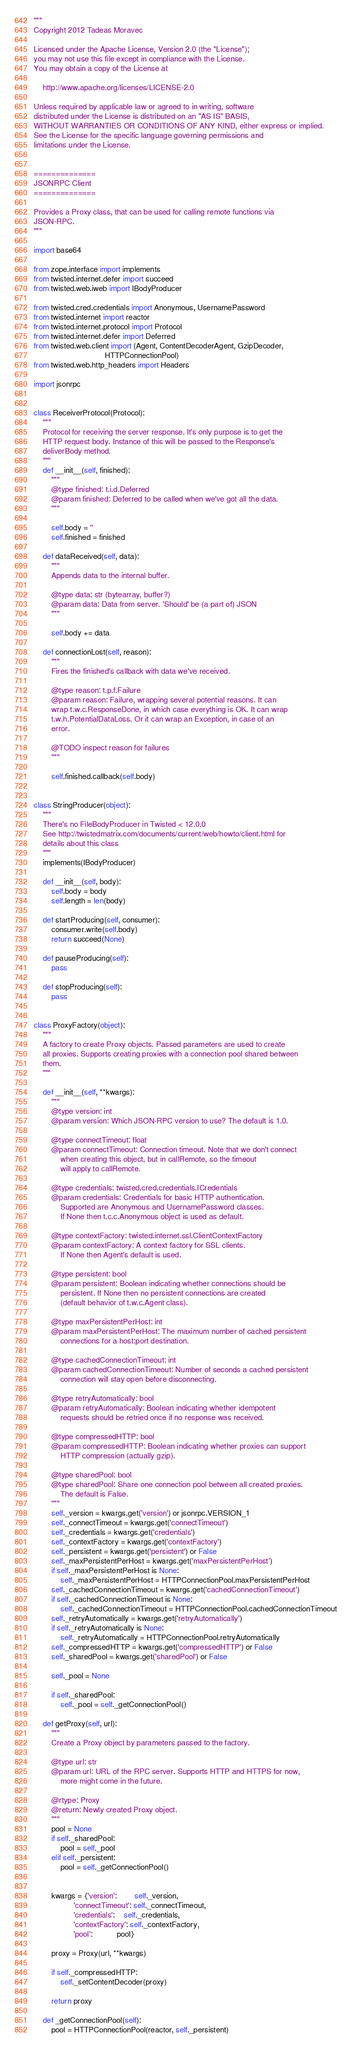<code> <loc_0><loc_0><loc_500><loc_500><_Python_>"""
Copyright 2012 Tadeas Moravec

Licensed under the Apache License, Version 2.0 (the "License");
you may not use this file except in compliance with the License.
You may obtain a copy of the License at

    http://www.apache.org/licenses/LICENSE-2.0

Unless required by applicable law or agreed to in writing, software
distributed under the License is distributed on an "AS IS" BASIS,
WITHOUT WARRANTIES OR CONDITIONS OF ANY KIND, either express or implied.
See the License for the specific language governing permissions and
limitations under the License.


==============
JSONRPC Client
==============

Provides a Proxy class, that can be used for calling remote functions via
JSON-RPC.
"""

import base64

from zope.interface import implements
from twisted.internet.defer import succeed
from twisted.web.iweb import IBodyProducer

from twisted.cred.credentials import Anonymous, UsernamePassword
from twisted.internet import reactor
from twisted.internet.protocol import Protocol
from twisted.internet.defer import Deferred
from twisted.web.client import (Agent, ContentDecoderAgent, GzipDecoder,
                                HTTPConnectionPool)
from twisted.web.http_headers import Headers

import jsonrpc


class ReceiverProtocol(Protocol):
    """
    Protocol for receiving the server response. It's only purpose is to get the
    HTTP request body. Instance of this will be passed to the Response's
    deliverBody method.
    """
    def __init__(self, finished):
        """
        @type finished: t.i.d.Deferred
        @param finished: Deferred to be called when we've got all the data.
        """

        self.body = ''
        self.finished = finished

    def dataReceived(self, data):
        """
        Appends data to the internal buffer.

        @type data: str (bytearray, buffer?)
        @param data: Data from server. 'Should' be (a part of) JSON
        """

        self.body += data

    def connectionLost(self, reason):
        """
        Fires the finished's callback with data we've received.

        @type reason: t.p.f.Failure
        @param reason: Failure, wrapping several potential reasons. It can
        wrap t.w.c.ResponseDone, in which case everything is OK. It can wrap
        t.w.h.PotentialDataLoss. Or it can wrap an Exception, in case of an
        error.

        @TODO inspect reason for failures
        """

        self.finished.callback(self.body)


class StringProducer(object):
    """
    There's no FileBodyProducer in Twisted < 12.0.0
    See http://twistedmatrix.com/documents/current/web/howto/client.html for
    details about this class
    """
    implements(IBodyProducer)

    def __init__(self, body):
        self.body = body
        self.length = len(body)

    def startProducing(self, consumer):
        consumer.write(self.body)
        return succeed(None)

    def pauseProducing(self):
        pass

    def stopProducing(self):
        pass


class ProxyFactory(object):
    """
    A factory to create Proxy objects. Passed parameters are used to create
    all proxies. Supports creating proxies with a connection pool shared between
    them.
    """

    def __init__(self, **kwargs):
        """
        @type version: int
        @param version: Which JSON-RPC version to use? The default is 1.0.

        @type connectTimeout: float
        @param connectTimeout: Connection timeout. Note that we don't connect
            when creating this object, but in callRemote, so the timeout
            will apply to callRemote.

        @type credentials: twisted.cred.credentials.ICredentials
        @param credentials: Credentials for basic HTTP authentication.
            Supported are Anonymous and UsernamePassword classes.
            If None then t.c.c.Anonymous object is used as default.

        @type contextFactory: twisted.internet.ssl.ClientContextFactory
        @param contextFactory: A context factory for SSL clients.
            If None then Agent's default is used.

        @type persistent: bool
        @param persistent: Boolean indicating whether connections should be
            persistent. If None then no persistent connections are created
            (default behavior of t.w.c.Agent class).

        @type maxPersistentPerHost: int
        @param maxPersistentPerHost: The maximum number of cached persistent
            connections for a host:port destination.

        @type cachedConnectionTimeout: int
        @param cachedConnectionTimeout: Number of seconds a cached persistent
            connection will stay open before disconnecting.

        @type retryAutomatically: bool
        @param retryAutomatically: Boolean indicating whether idempotent
            requests should be retried once if no response was received.

        @type compressedHTTP: bool
        @param compressedHTTP: Boolean indicating whether proxies can support
            HTTP compression (actually gzip).

        @type sharedPool: bool
        @type sharedPool: Share one connection pool between all created proxies.
            The default is False.
        """
        self._version = kwargs.get('version') or jsonrpc.VERSION_1
        self._connectTimeout = kwargs.get('connectTimeout')
        self._credentials = kwargs.get('credentials')
        self._contextFactory = kwargs.get('contextFactory')
        self._persistent = kwargs.get('persistent') or False
        self._maxPersistentPerHost = kwargs.get('maxPersistentPerHost')
        if self._maxPersistentPerHost is None:
            self._maxPersistentPerHost = HTTPConnectionPool.maxPersistentPerHost
        self._cachedConnectionTimeout = kwargs.get('cachedConnectionTimeout')
        if self._cachedConnectionTimeout is None:
            self._cachedConnectionTimeout = HTTPConnectionPool.cachedConnectionTimeout
        self._retryAutomatically = kwargs.get('retryAutomatically')
        if self._retryAutomatically is None:
            self._retryAutomatically = HTTPConnectionPool.retryAutomatically
        self._compressedHTTP = kwargs.get('compressedHTTP') or False
        self._sharedPool = kwargs.get('sharedPool') or False

        self._pool = None

        if self._sharedPool:
            self._pool = self._getConnectionPool()

    def getProxy(self, url):
        """
        Create a Proxy object by parameters passed to the factory.

        @type url: str
        @param url: URL of the RPC server. Supports HTTP and HTTPS for now,
            more might come in the future.

        @rtype: Proxy
        @return: Newly created Proxy object.
        """
        pool = None
        if self._sharedPool:
            pool = self._pool
        elif self._persistent:
            pool = self._getConnectionPool()


        kwargs = {'version':        self._version,
                  'connectTimeout': self._connectTimeout,
                  'credentials':    self._credentials,
                  'contextFactory': self._contextFactory,
                  'pool':           pool}

        proxy = Proxy(url, **kwargs)

        if self._compressedHTTP:
            self._setContentDecoder(proxy)

        return proxy

    def _getConnectionPool(self):
        pool = HTTPConnectionPool(reactor, self._persistent)
</code> 